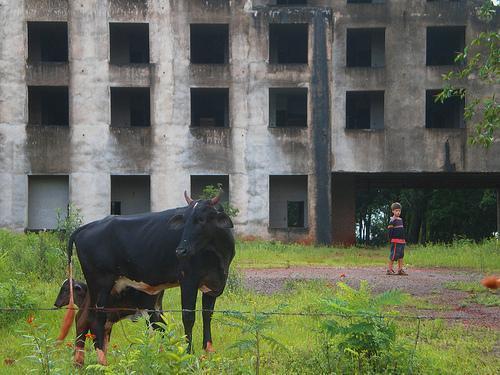How many animals are shown?
Give a very brief answer. 2. 